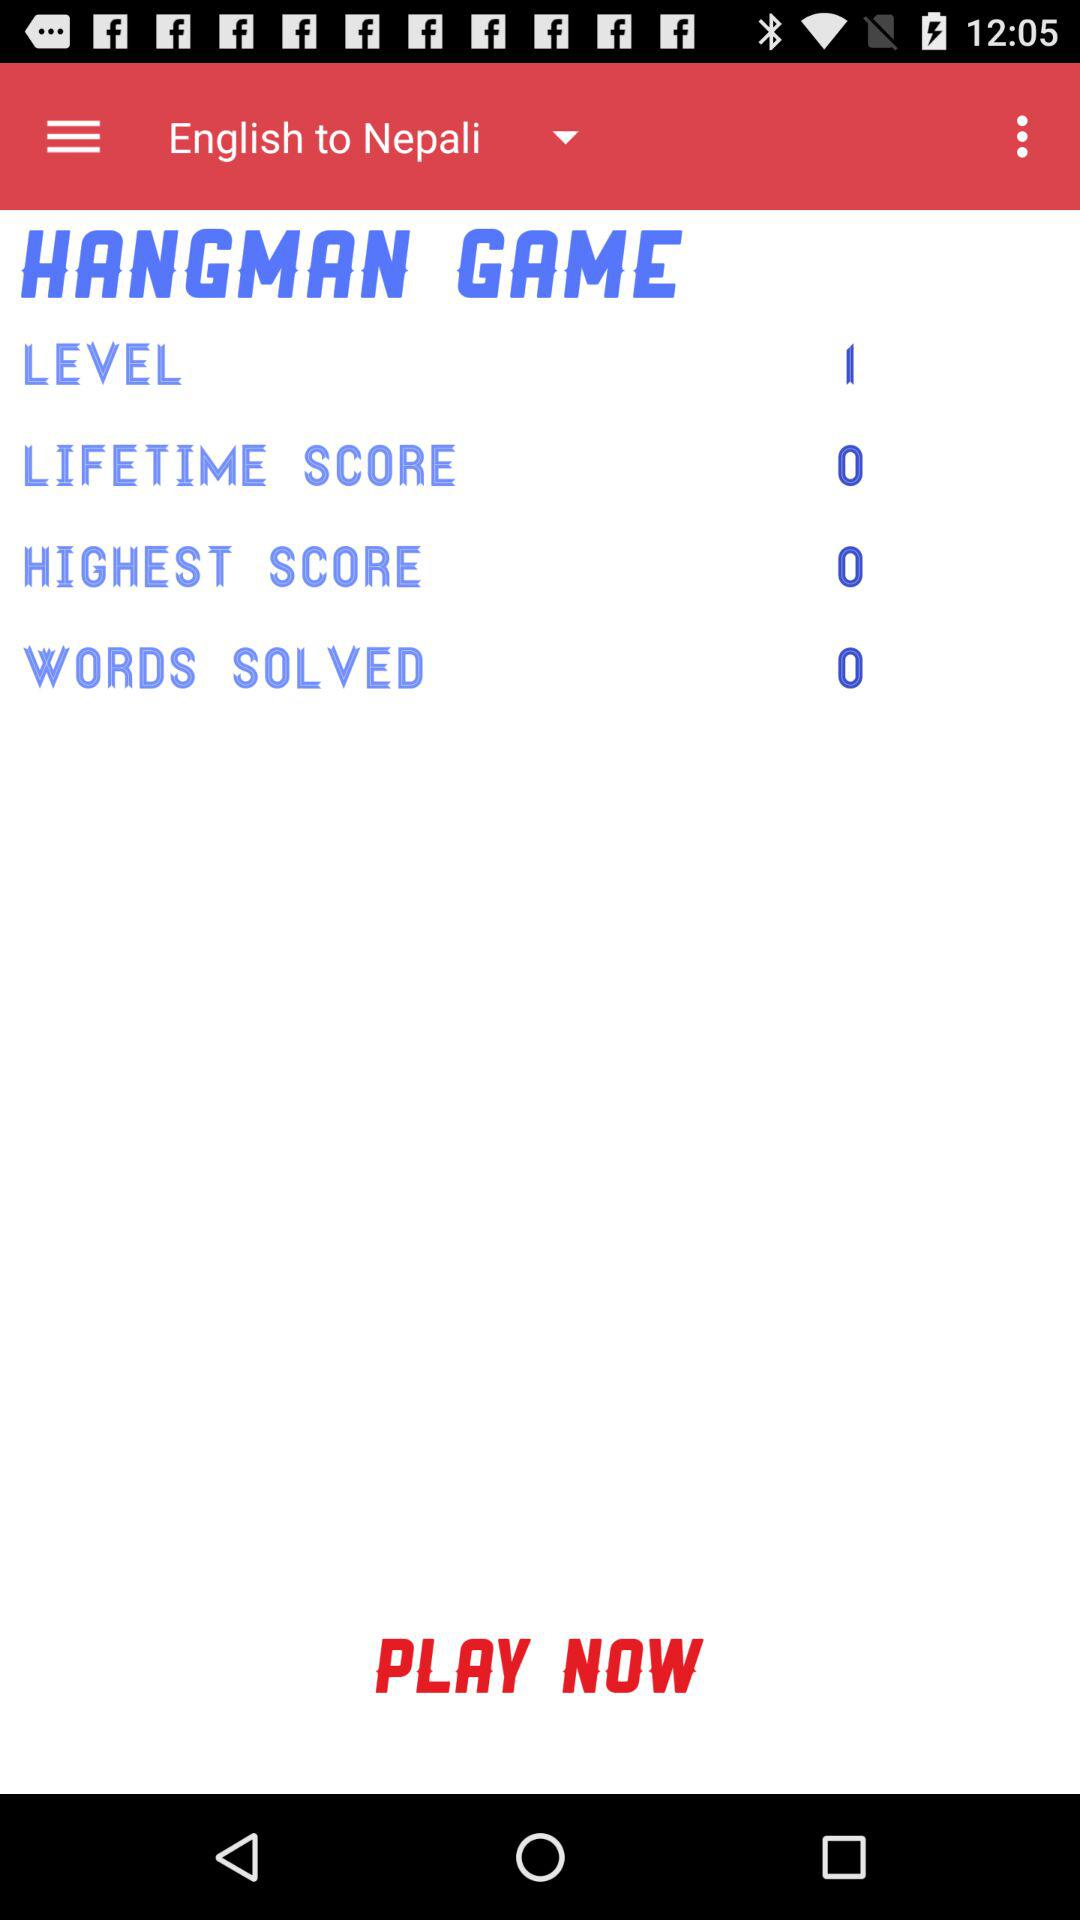What is the highest score? The highest score is 0. 